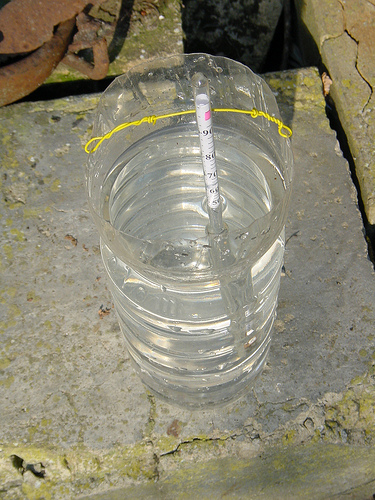<image>
Can you confirm if the bottle is in the water? No. The bottle is not contained within the water. These objects have a different spatial relationship. 